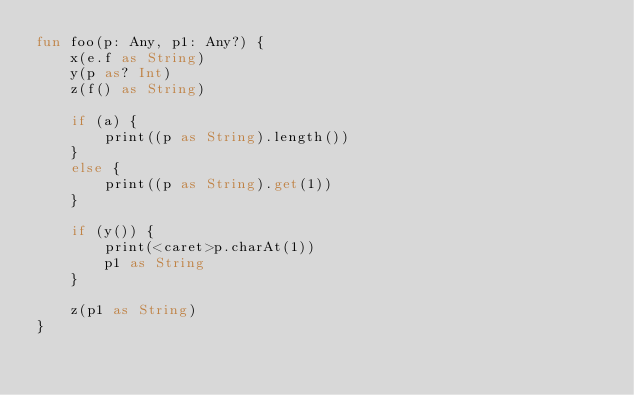Convert code to text. <code><loc_0><loc_0><loc_500><loc_500><_Kotlin_>fun foo(p: Any, p1: Any?) {
    x(e.f as String)
    y(p as? Int)
    z(f() as String)

    if (a) {
        print((p as String).length())
    }
    else {
        print((p as String).get(1))
    }

    if (y()) {
        print(<caret>p.charAt(1))
        p1 as String
    }

    z(p1 as String)
}
</code> 